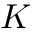Convert formula to latex. <formula><loc_0><loc_0><loc_500><loc_500>K</formula> 